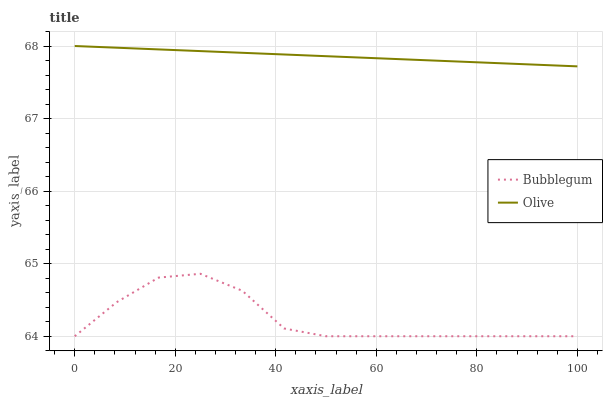Does Bubblegum have the minimum area under the curve?
Answer yes or no. Yes. Does Olive have the maximum area under the curve?
Answer yes or no. Yes. Does Bubblegum have the maximum area under the curve?
Answer yes or no. No. Is Olive the smoothest?
Answer yes or no. Yes. Is Bubblegum the roughest?
Answer yes or no. Yes. Is Bubblegum the smoothest?
Answer yes or no. No. Does Bubblegum have the highest value?
Answer yes or no. No. Is Bubblegum less than Olive?
Answer yes or no. Yes. Is Olive greater than Bubblegum?
Answer yes or no. Yes. Does Bubblegum intersect Olive?
Answer yes or no. No. 